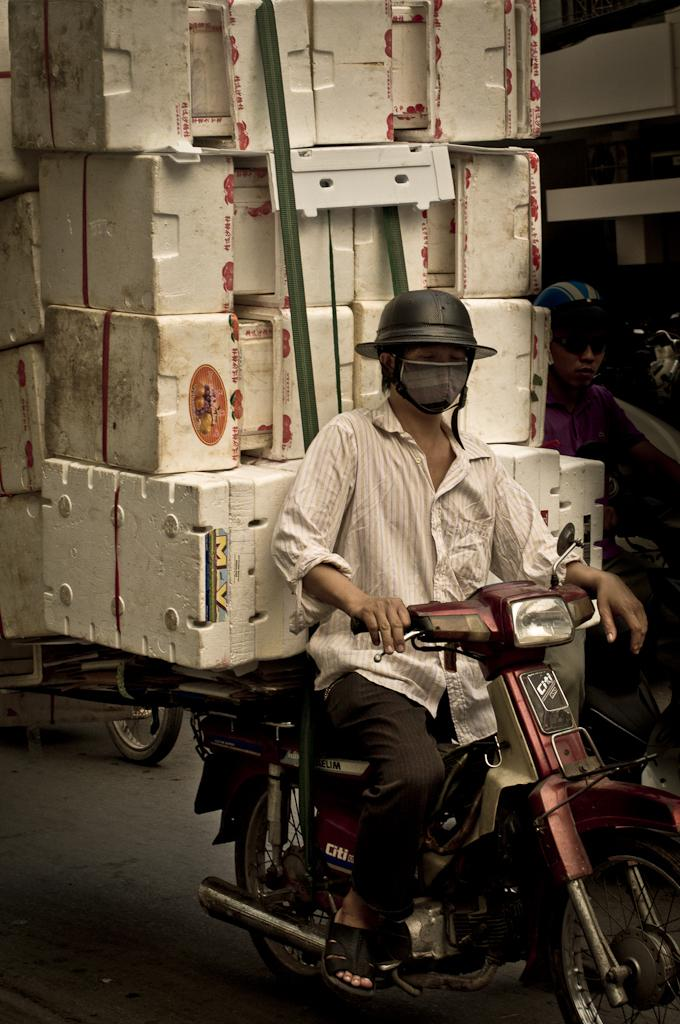What is the man in the image doing? The man is riding a motorbike in the image. What safety precaution is the man taking while riding the motorbike? The man is wearing a helmet. What is behind the man on the motorbike? There are boxes behind the man. What is the other person in the image doing? Another person is riding a vehicle. What safety precaution is the other person taking? The other person is also wearing a helmet. What can be seen in the background of the image? There is a building in the image. How many bears are sitting on the engine of the motorbike? There are no bears present in the image, and the motorbike does not have an engine. Is there a hook attached to the helmet of the person riding the vehicle? There is no hook attached to the helmet of the person riding the vehicle in the image. 